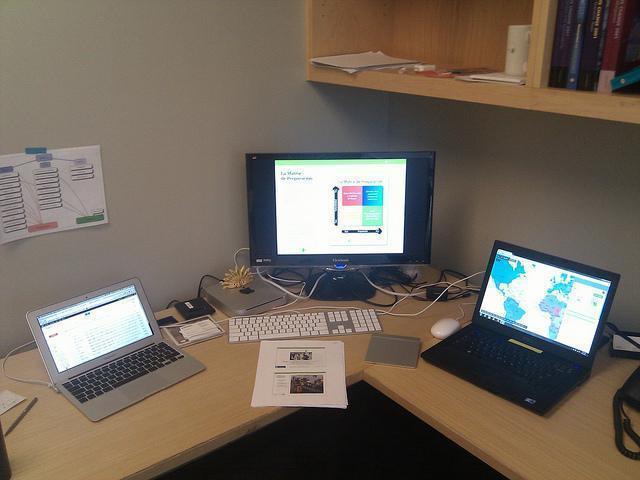On which computer could one find directions the fastest?
Pick the correct solution from the four options below to address the question.
Options: Middle, left, none, right. Right. 